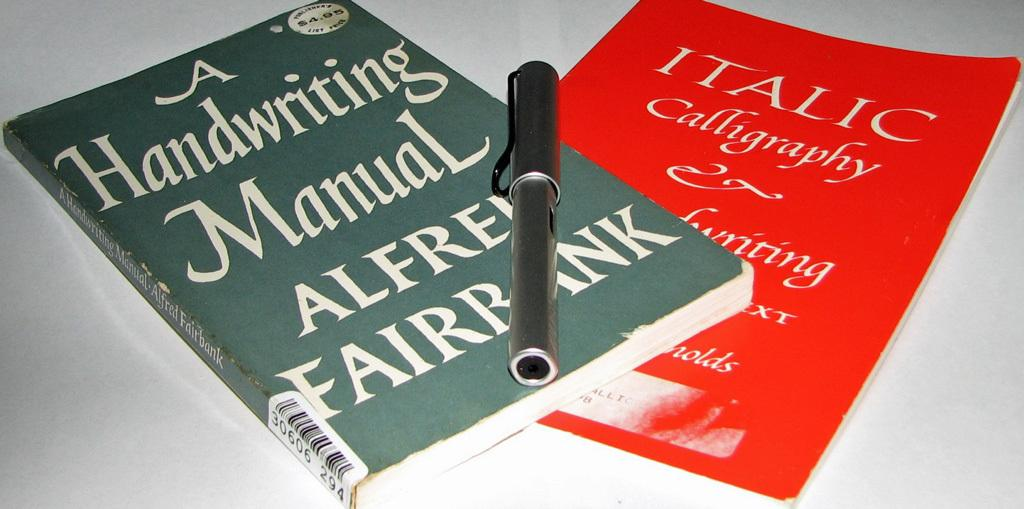<image>
Present a compact description of the photo's key features. two books stack with one titled A Handwriting Manual by Alfred Fairbank 